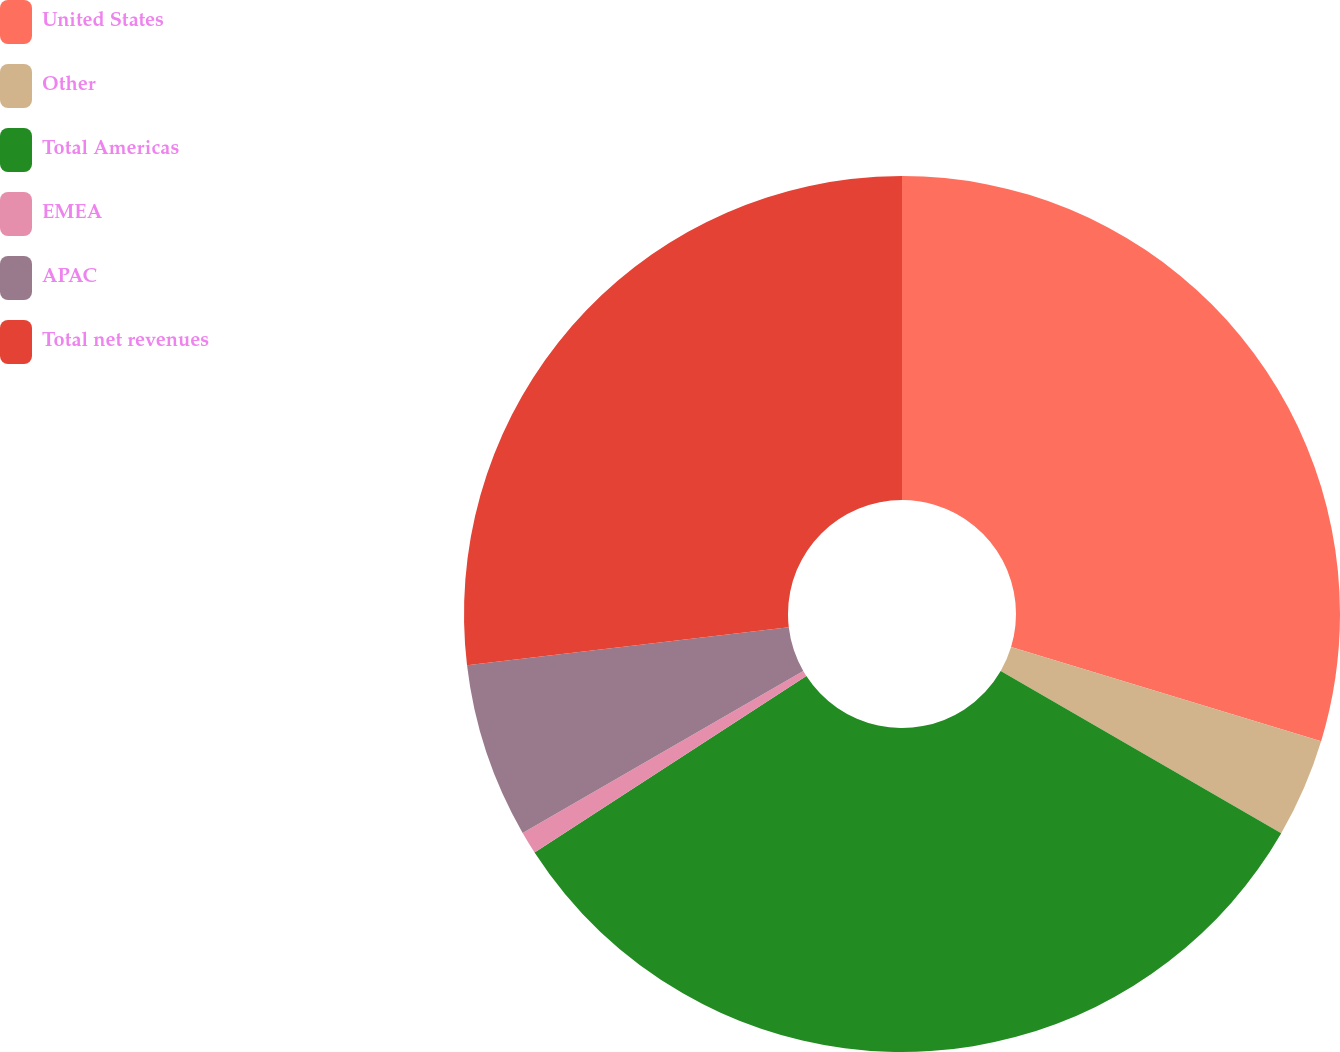Convert chart to OTSL. <chart><loc_0><loc_0><loc_500><loc_500><pie_chart><fcel>United States<fcel>Other<fcel>Total Americas<fcel>EMEA<fcel>APAC<fcel>Total net revenues<nl><fcel>29.69%<fcel>3.65%<fcel>32.5%<fcel>0.83%<fcel>6.46%<fcel>26.87%<nl></chart> 